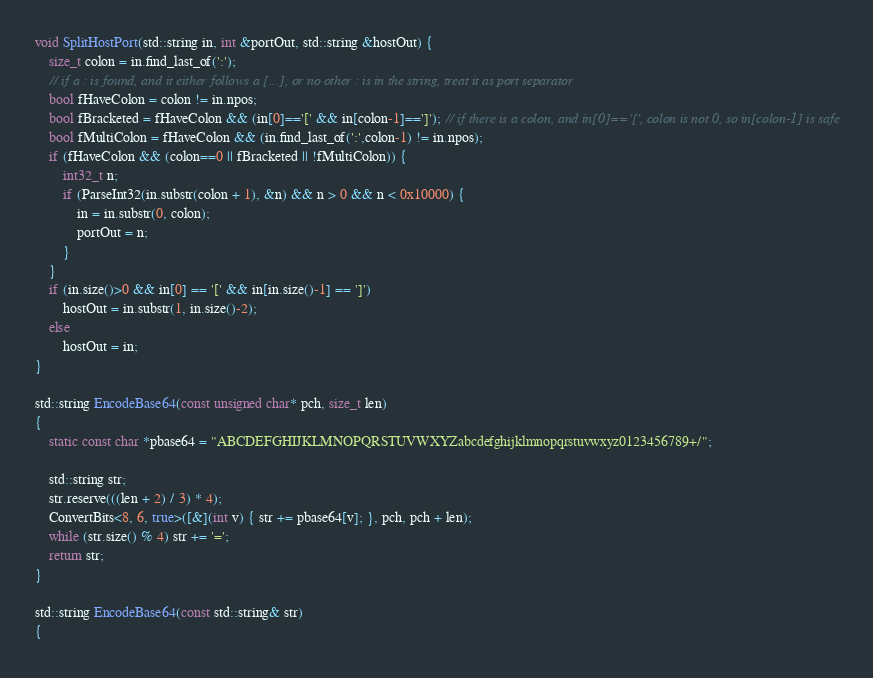Convert code to text. <code><loc_0><loc_0><loc_500><loc_500><_C++_>void SplitHostPort(std::string in, int &portOut, std::string &hostOut) {
    size_t colon = in.find_last_of(':');
    // if a : is found, and it either follows a [...], or no other : is in the string, treat it as port separator
    bool fHaveColon = colon != in.npos;
    bool fBracketed = fHaveColon && (in[0]=='[' && in[colon-1]==']'); // if there is a colon, and in[0]=='[', colon is not 0, so in[colon-1] is safe
    bool fMultiColon = fHaveColon && (in.find_last_of(':',colon-1) != in.npos);
    if (fHaveColon && (colon==0 || fBracketed || !fMultiColon)) {
        int32_t n;
        if (ParseInt32(in.substr(colon + 1), &n) && n > 0 && n < 0x10000) {
            in = in.substr(0, colon);
            portOut = n;
        }
    }
    if (in.size()>0 && in[0] == '[' && in[in.size()-1] == ']')
        hostOut = in.substr(1, in.size()-2);
    else
        hostOut = in;
}

std::string EncodeBase64(const unsigned char* pch, size_t len)
{
    static const char *pbase64 = "ABCDEFGHIJKLMNOPQRSTUVWXYZabcdefghijklmnopqrstuvwxyz0123456789+/";

    std::string str;
    str.reserve(((len + 2) / 3) * 4);
    ConvertBits<8, 6, true>([&](int v) { str += pbase64[v]; }, pch, pch + len);
    while (str.size() % 4) str += '=';
    return str;
}

std::string EncodeBase64(const std::string& str)
{</code> 